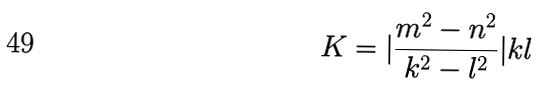Convert formula to latex. <formula><loc_0><loc_0><loc_500><loc_500>K = | \frac { m ^ { 2 } - n ^ { 2 } } { k ^ { 2 } - l ^ { 2 } } | k l</formula> 